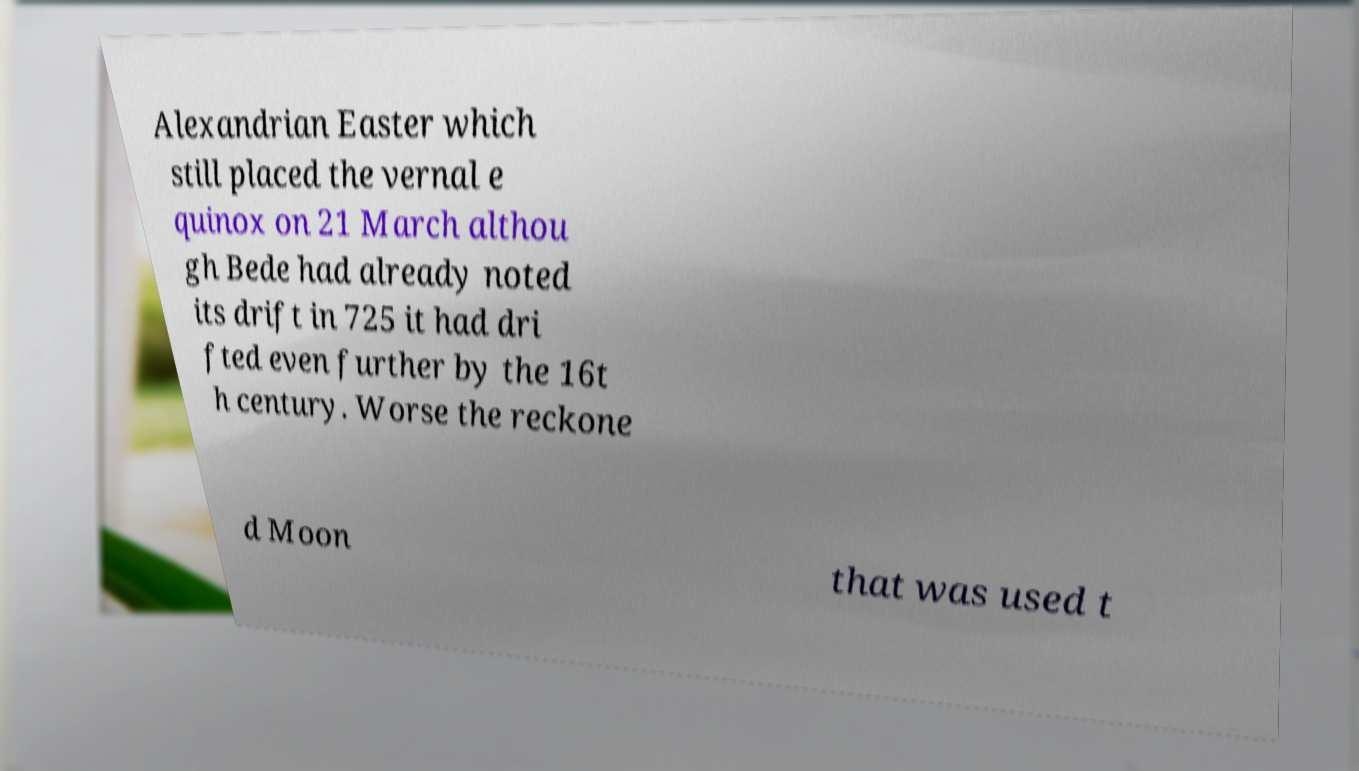There's text embedded in this image that I need extracted. Can you transcribe it verbatim? Alexandrian Easter which still placed the vernal e quinox on 21 March althou gh Bede had already noted its drift in 725 it had dri fted even further by the 16t h century. Worse the reckone d Moon that was used t 